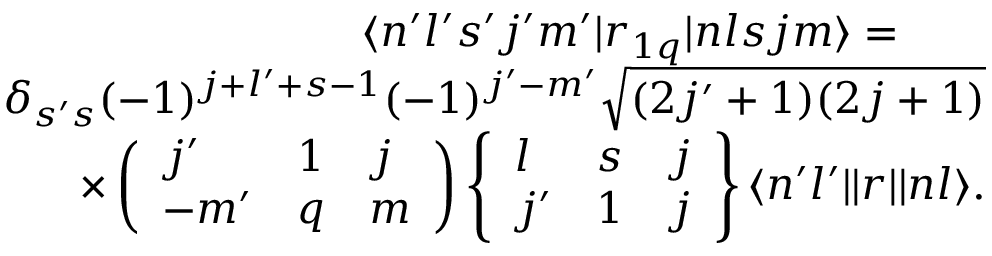<formula> <loc_0><loc_0><loc_500><loc_500>\begin{array} { r } { \langle n ^ { \prime } l ^ { \prime } s ^ { \prime } j ^ { \prime } m ^ { \prime } | r _ { 1 q } | n l s j m \rangle = \quad } \\ { \delta _ { s ^ { \prime } s } ( - 1 ) ^ { j + l ^ { \prime } + s - 1 } ( - 1 ) ^ { j ^ { \prime } - m ^ { \prime } } \sqrt { ( 2 j ^ { \prime } + 1 ) ( 2 j + 1 ) } } \\ { \times \left ( \begin{array} { l l l } { j ^ { \prime } } & { 1 } & { j } \\ { - m ^ { \prime } } & { q } & { m } \end{array} \right ) \left \{ \begin{array} { l l l } { l } & { s } & { j } \\ { j ^ { \prime } } & { 1 } & { j } \end{array} \right \} \langle n ^ { \prime } l ^ { \prime } | | r | | n l \rangle . } \end{array}</formula> 